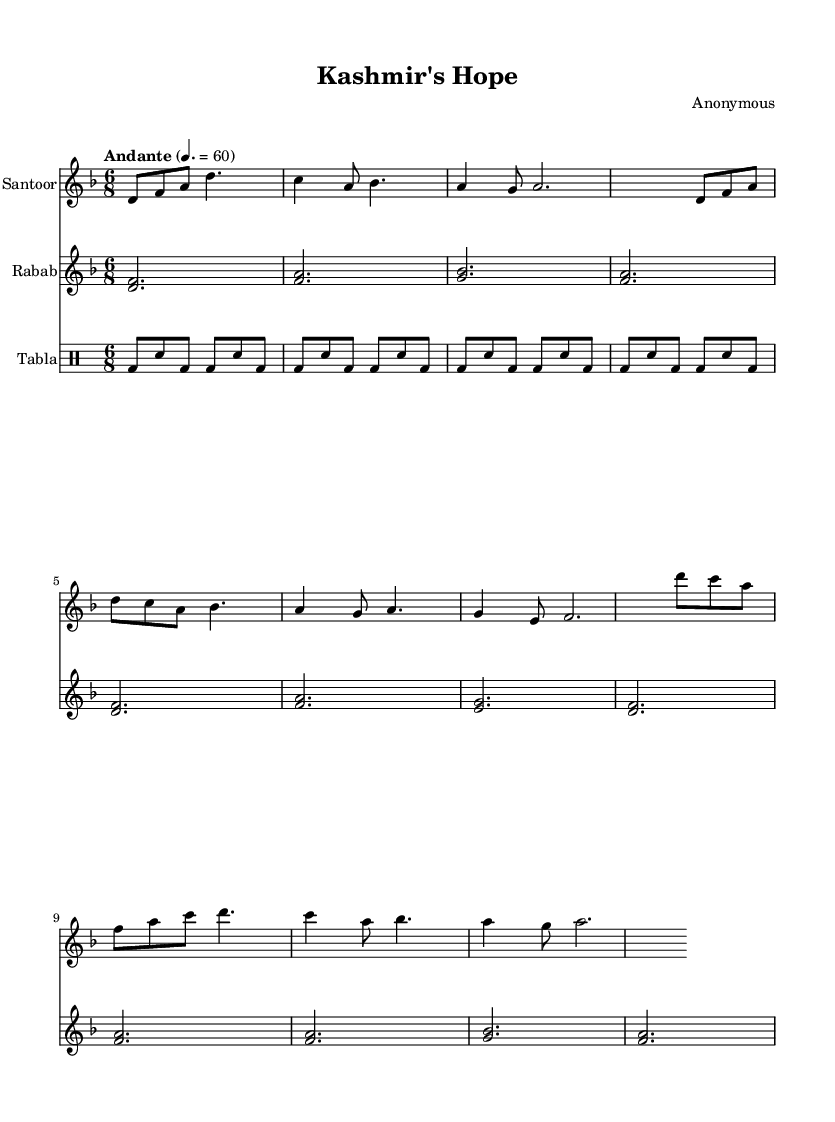What is the key signature of this music? The key signature indicates the scale in which the piece is written. In this sheet music, the symbol shows one flat at the beginning, which corresponds to D minor.
Answer: D minor What is the time signature of this music? The time signature is represented at the beginning of the score and indicates how many beats are in each measure. Here, it is written as 6 over 8, meaning there are six eighth notes per measure.
Answer: 6/8 What is the tempo marking of this piece? The tempo marking "Andante" informs us about the speed of the performance, and the following number indicates its beats per minute. Here, it states "Andante" and a tempo of 60 beats per minute.
Answer: Andante, 60 How many distinct sections are in the santoor part? By analyzing the structure of the santoor part, we can identify the introduction, verse, and chorus as three distinct sections.
Answer: Three Which traditional Kashmiri instruments are featured in this piece? The score lists specific instruments: the santoor, rabab, and tabla, each serving a unique role in the composition, showcasing the instrumental diversity of Kashmir.
Answer: Santoor, rabab, tabla What is the basic rhythmic pattern used in the tabla part? The tabla section uses a repeated pattern consisting of bass (bd) and snare (sn) sounds. This pattern repeats eight times across four measures, creating a driving rhythmic foundation.
Answer: Bass-snare pattern In which voice does the melody generally rise in the chorus? Observing the melodic contour in the chorus of the santoor part, we note the melody peaks on the high note 'd', indicating a rise in pitch during this section.
Answer: 'd' 